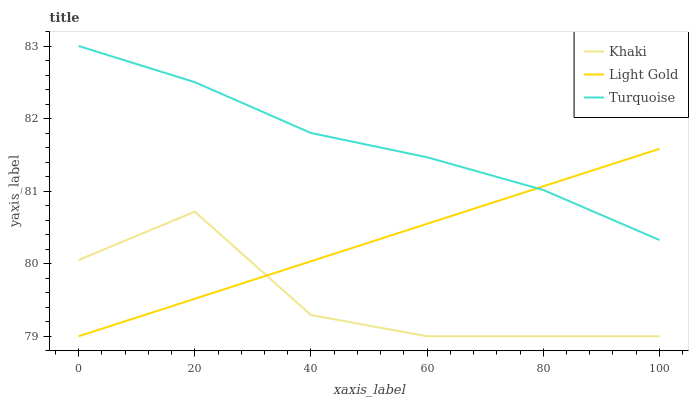Does Khaki have the minimum area under the curve?
Answer yes or no. Yes. Does Turquoise have the maximum area under the curve?
Answer yes or no. Yes. Does Light Gold have the minimum area under the curve?
Answer yes or no. No. Does Light Gold have the maximum area under the curve?
Answer yes or no. No. Is Light Gold the smoothest?
Answer yes or no. Yes. Is Khaki the roughest?
Answer yes or no. Yes. Is Khaki the smoothest?
Answer yes or no. No. Is Light Gold the roughest?
Answer yes or no. No. Does Khaki have the lowest value?
Answer yes or no. Yes. Does Turquoise have the highest value?
Answer yes or no. Yes. Does Light Gold have the highest value?
Answer yes or no. No. Is Khaki less than Turquoise?
Answer yes or no. Yes. Is Turquoise greater than Khaki?
Answer yes or no. Yes. Does Khaki intersect Light Gold?
Answer yes or no. Yes. Is Khaki less than Light Gold?
Answer yes or no. No. Is Khaki greater than Light Gold?
Answer yes or no. No. Does Khaki intersect Turquoise?
Answer yes or no. No. 